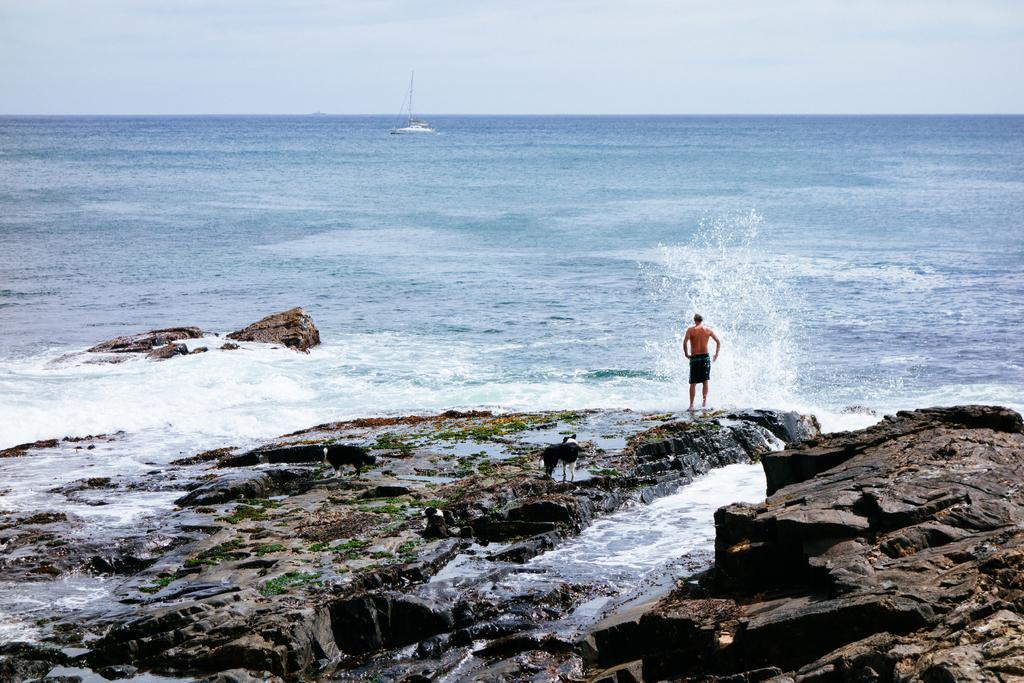In one or two sentences, can you explain what this image depicts? In this image I can see a dog and a man. I can see both of them are standing on the rock surface. I can see the man is wearing a shorts. In the background I can see water, clouds, the sky and a white colour boat on the water. 